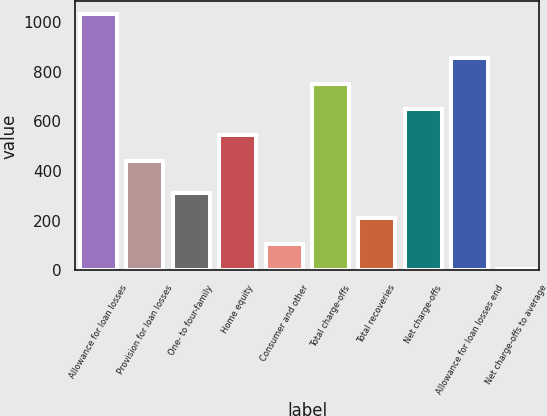Convert chart. <chart><loc_0><loc_0><loc_500><loc_500><bar_chart><fcel>Allowance for loan losses<fcel>Provision for loan losses<fcel>One- to four-family<fcel>Home equity<fcel>Consumer and other<fcel>Total charge-offs<fcel>Total recoveries<fcel>Net charge-offs<fcel>Allowance for loan losses end<fcel>Net charge-offs to average<nl><fcel>1031.2<fcel>440.6<fcel>312.46<fcel>543.28<fcel>107.1<fcel>751.68<fcel>209.78<fcel>649<fcel>854.36<fcel>4.42<nl></chart> 